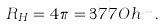<formula> <loc_0><loc_0><loc_500><loc_500>R _ { H } = 4 \pi = 3 7 7 O h m .</formula> 